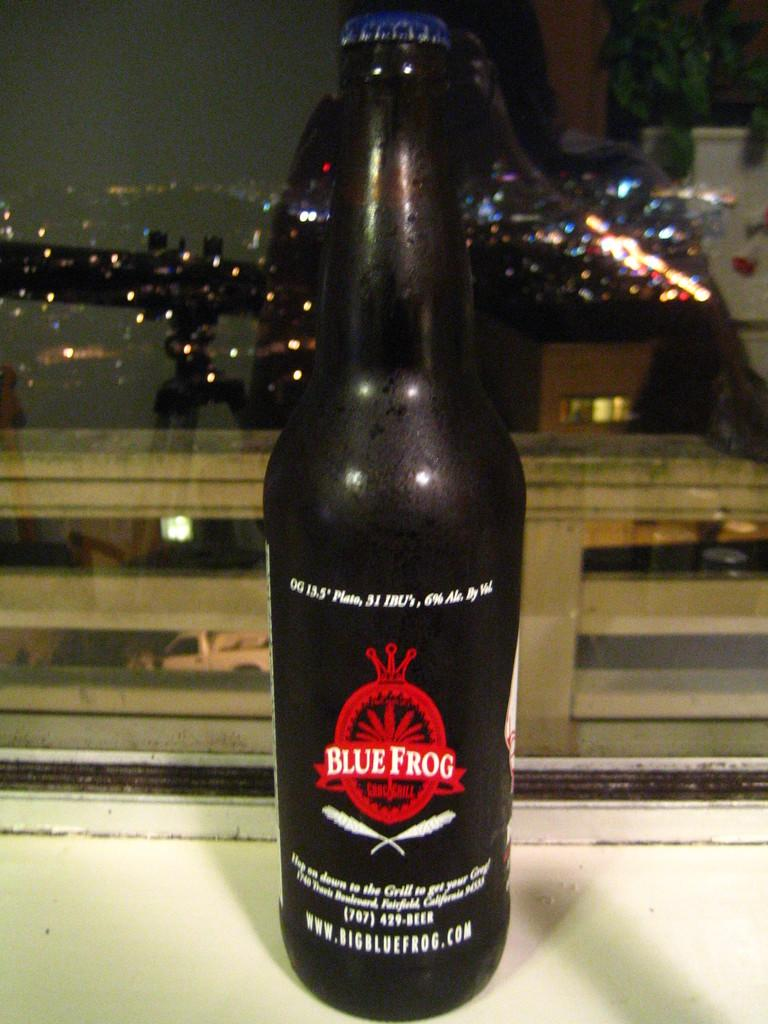What color is the bottle that is visible in the image? The bottle in the image is black. How is the black bottle emphasized in the image? The black bottle is highlighted in the image. What can be seen in the distance in the image? There are lights visible in the distance. What type of quince is being used to make the skirt in the image? There is no quince or skirt present in the image; it only features a black bottle and lights in the distance. 